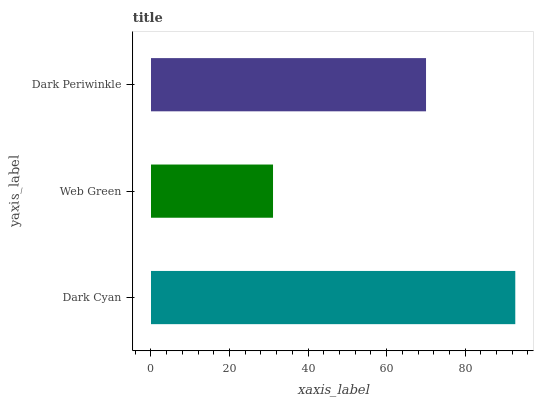Is Web Green the minimum?
Answer yes or no. Yes. Is Dark Cyan the maximum?
Answer yes or no. Yes. Is Dark Periwinkle the minimum?
Answer yes or no. No. Is Dark Periwinkle the maximum?
Answer yes or no. No. Is Dark Periwinkle greater than Web Green?
Answer yes or no. Yes. Is Web Green less than Dark Periwinkle?
Answer yes or no. Yes. Is Web Green greater than Dark Periwinkle?
Answer yes or no. No. Is Dark Periwinkle less than Web Green?
Answer yes or no. No. Is Dark Periwinkle the high median?
Answer yes or no. Yes. Is Dark Periwinkle the low median?
Answer yes or no. Yes. Is Web Green the high median?
Answer yes or no. No. Is Web Green the low median?
Answer yes or no. No. 